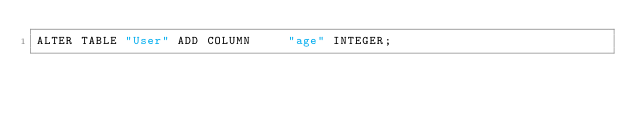<code> <loc_0><loc_0><loc_500><loc_500><_SQL_>ALTER TABLE "User" ADD COLUMN     "age" INTEGER;
</code> 